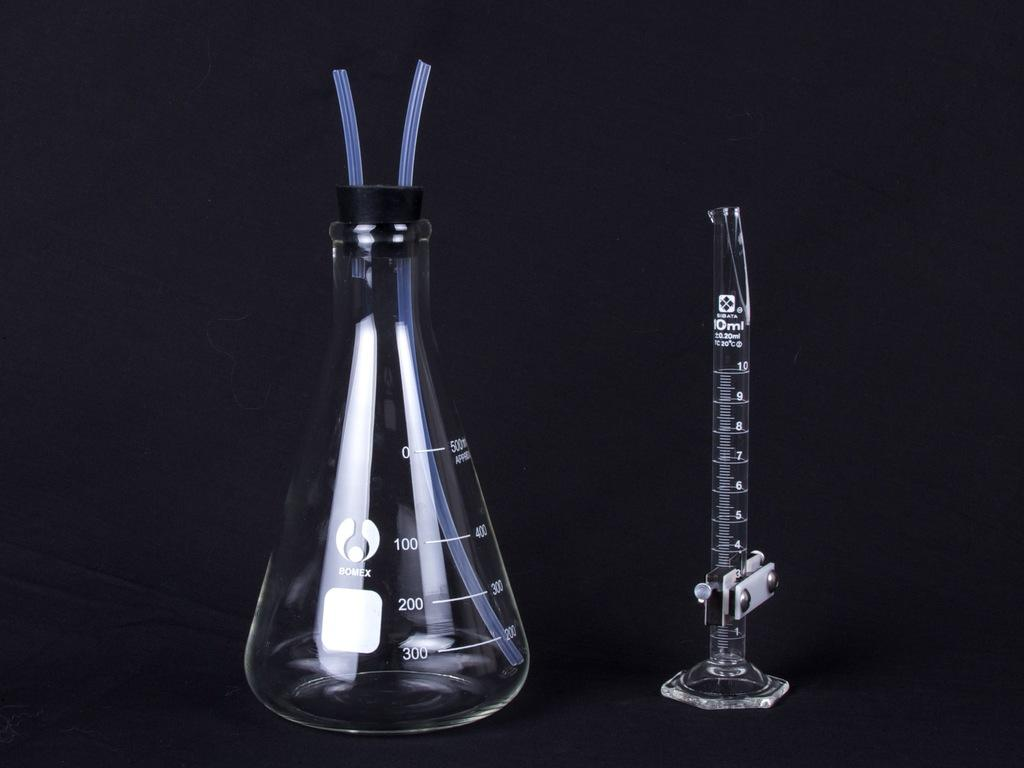<image>
Share a concise interpretation of the image provided. A beaker is on a table next to a 10 ml vial. 